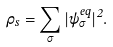Convert formula to latex. <formula><loc_0><loc_0><loc_500><loc_500>\rho _ { s } = \sum _ { \sigma } | \psi _ { \sigma } ^ { e q } | ^ { 2 } .</formula> 